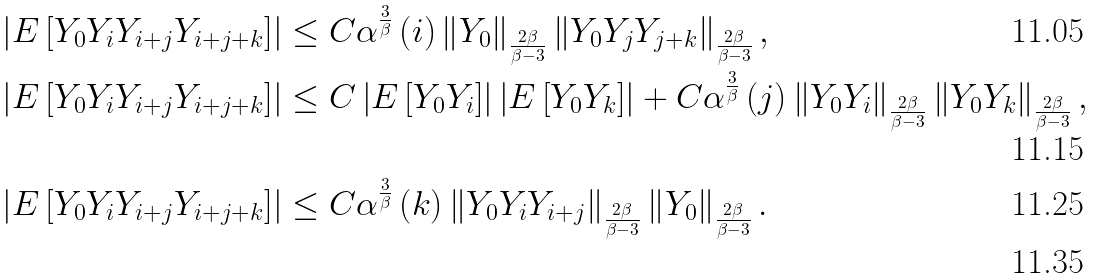Convert formula to latex. <formula><loc_0><loc_0><loc_500><loc_500>\left | E \left [ Y _ { 0 } Y _ { i } Y _ { i + j } Y _ { i + j + k } \right ] \right | & \leq C \alpha ^ { \frac { 3 } { \beta } } \left ( i \right ) \left \| Y _ { 0 } \right \| _ { \frac { 2 \beta } { \beta - 3 } } \left \| Y _ { 0 } Y _ { j } Y _ { j + k } \right \| _ { \frac { 2 \beta } { \beta - 3 } } , \\ \left | E \left [ Y _ { 0 } Y _ { i } Y _ { i + j } Y _ { i + j + k } \right ] \right | & \leq C \left | E \left [ Y _ { 0 } Y _ { i } \right ] \right | \left | E \left [ Y _ { 0 } Y _ { k } \right ] \right | + C \alpha ^ { \frac { 3 } { \beta } } \left ( j \right ) \left \| Y _ { 0 } Y _ { i } \right \| _ { \frac { 2 \beta } { \beta - 3 } } \left \| Y _ { 0 } Y _ { k } \right \| _ { \frac { 2 \beta } { \beta - 3 } } , \\ \left | E \left [ Y _ { 0 } Y _ { i } Y _ { i + j } Y _ { i + j + k } \right ] \right | & \leq C \alpha ^ { \frac { 3 } { \beta } } \left ( k \right ) \left \| Y _ { 0 } Y _ { i } Y _ { i + j } \right \| _ { \frac { 2 \beta } { \beta - 3 } } \left \| Y _ { 0 } \right \| _ { \frac { 2 \beta } { \beta - 3 } } . \\</formula> 